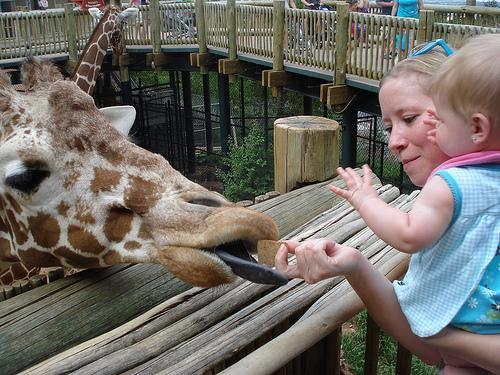How many giraffes are the people feeding?
Give a very brief answer. 1. 